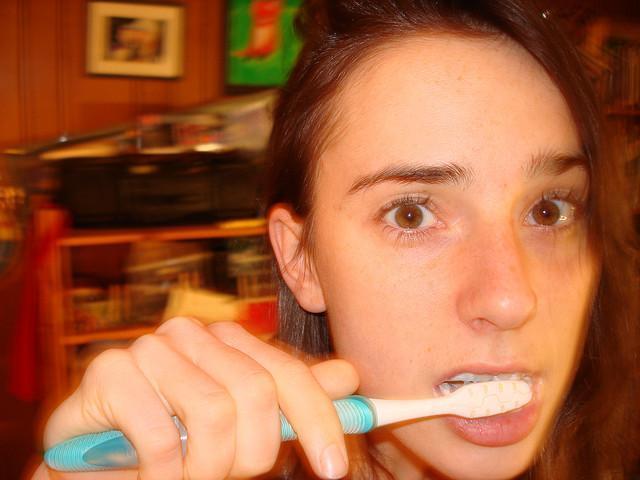How many toothbrushes are there?
Give a very brief answer. 1. How many sheep can be seen?
Give a very brief answer. 0. 